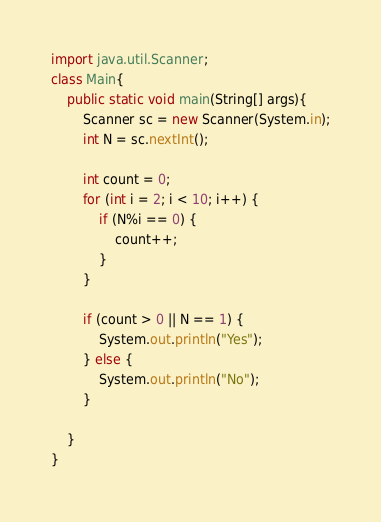Convert code to text. <code><loc_0><loc_0><loc_500><loc_500><_Java_>import java.util.Scanner;
class Main{
    public static void main(String[] args){
        Scanner sc = new Scanner(System.in);
        int N = sc.nextInt();
        
        int count = 0;
        for (int i = 2; i < 10; i++) {
            if (N%i == 0) {
                count++;
            }
        }
        
        if (count > 0 || N == 1) {
            System.out.println("Yes");
        } else {
            System.out.println("No");
        }

    }
}</code> 